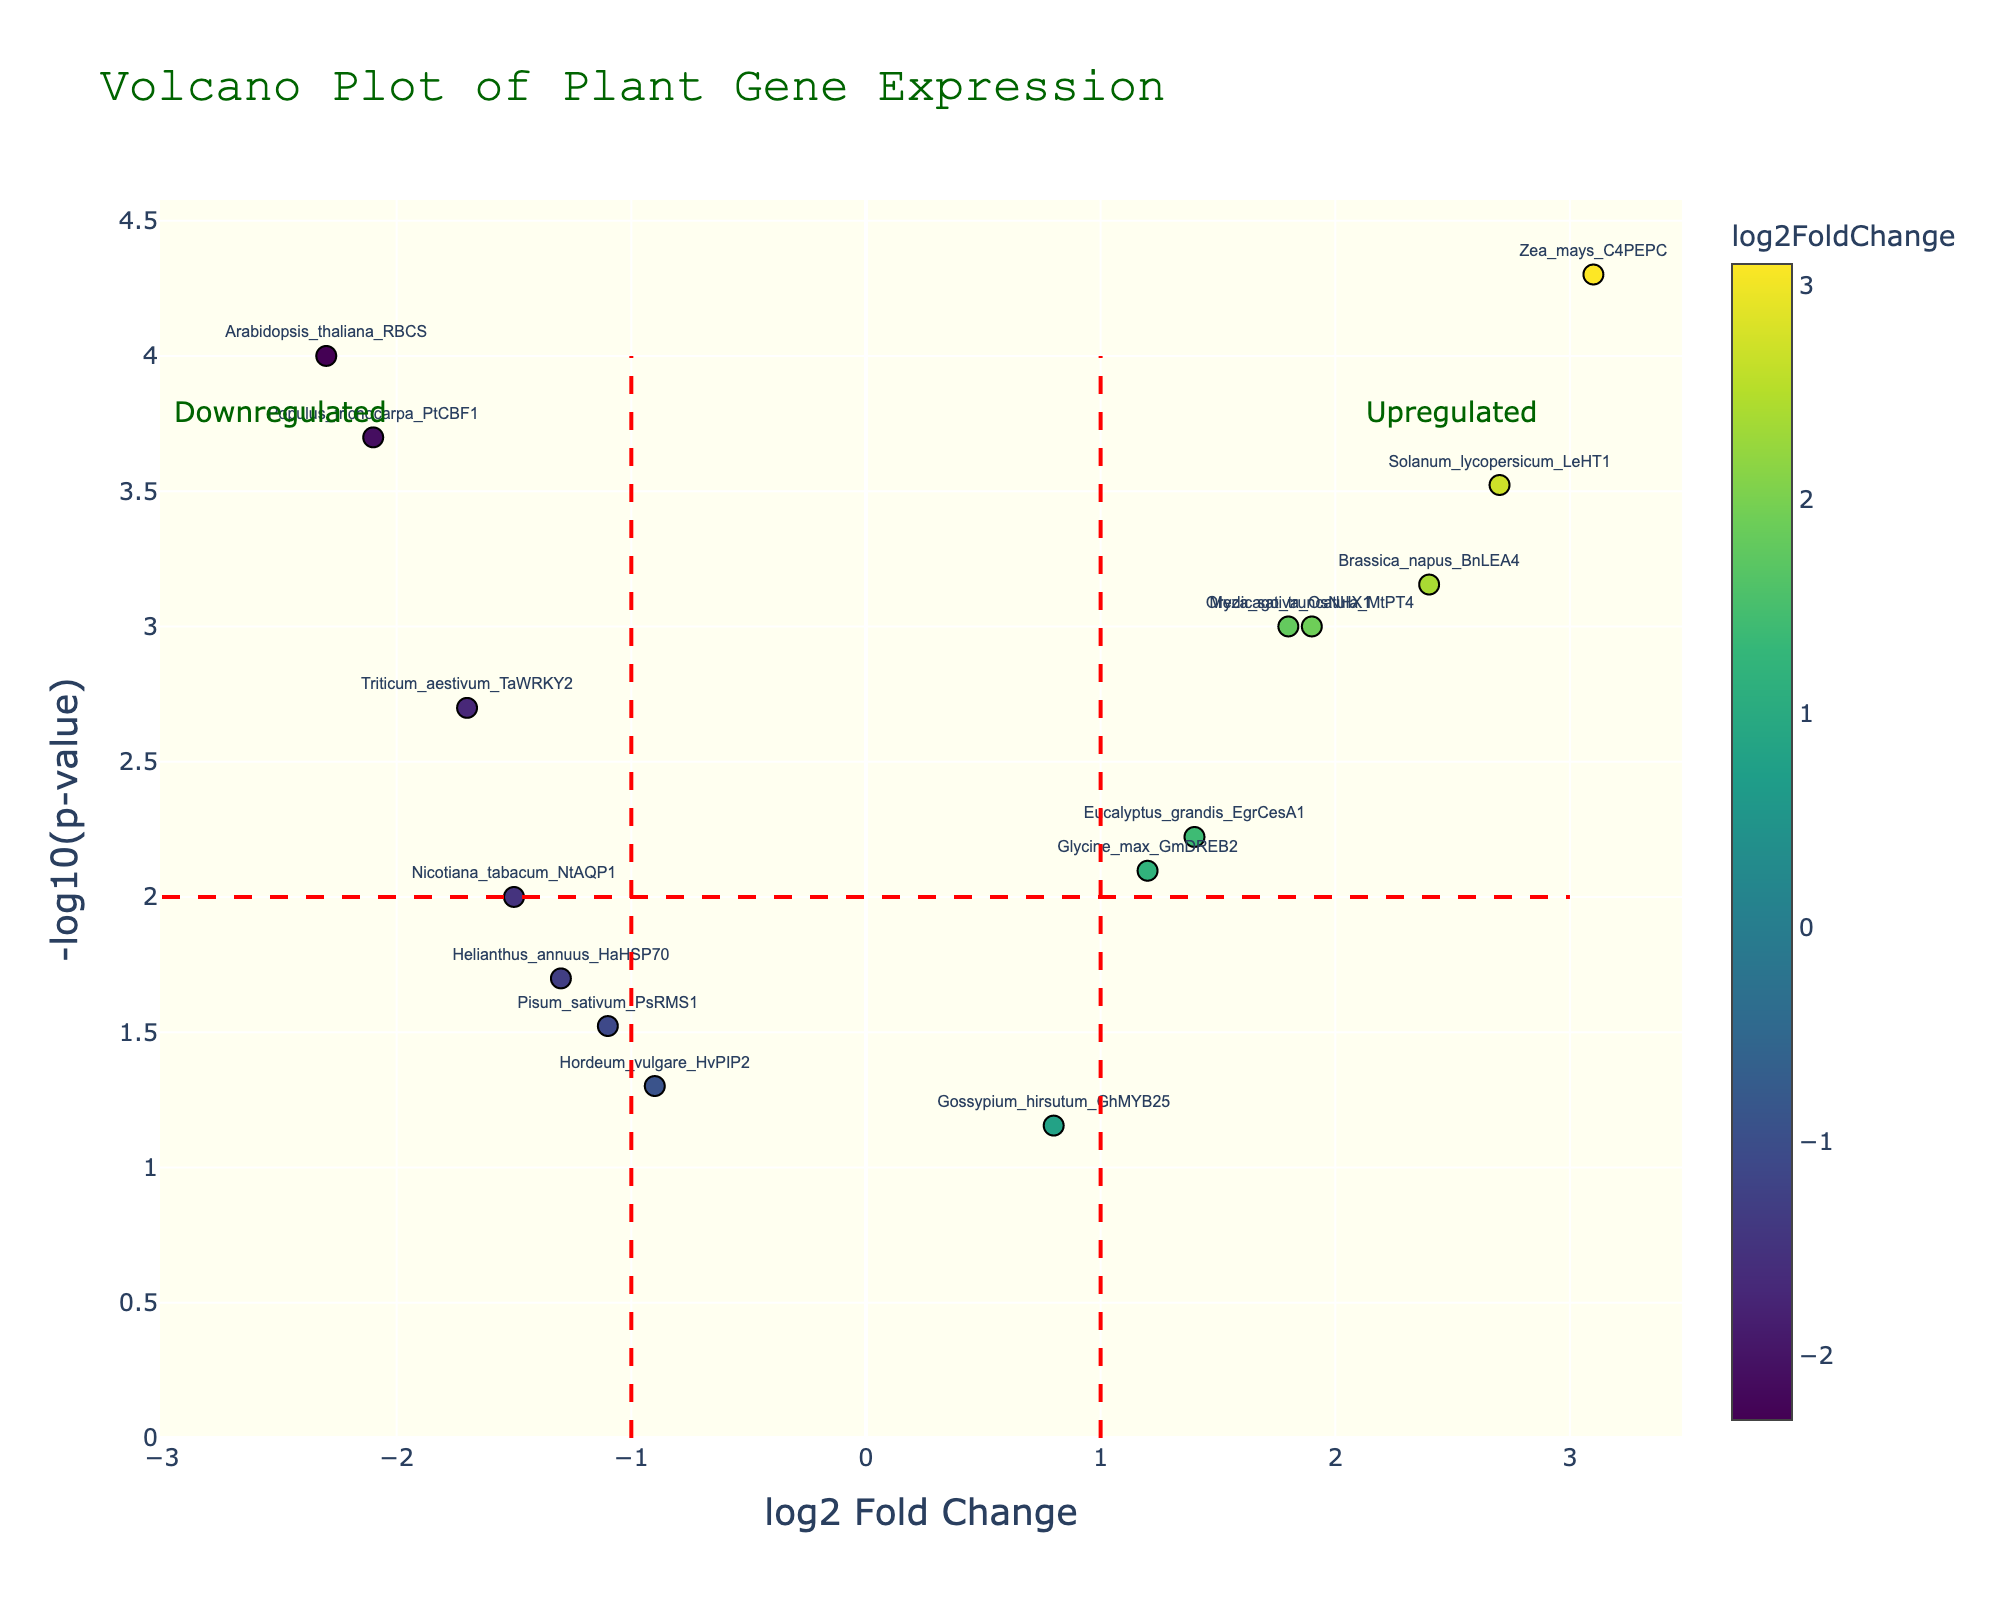What is the title of the plot? The title of the plot is prominently displayed at the top center and reads "Volcano Plot of Plant Gene Expression".
Answer: Volcano Plot of Plant Gene Expression What are the axes labels in the figure? The figure has two axes: the x-axis is labeled "log2 Fold Change" and the y-axis is labeled "-log10(p-value)".
Answer: log2 Fold Change, -log10(p-value) How many genes are labeled in the plot? By visually counting the number of data points annotated with gene names, there are 15 labeled genes in the plot.
Answer: 15 Which gene shows the greatest upregulation? The gene with the highest log2 Fold Change value represents the greatest upregulation, which is "Zea_mays_C4PEPC" with a log2 Fold Change of 3.1.
Answer: Zea_mays_C4PEPC What color scale is used in the plot? The color scale used is "Viridis", which moves from dark to light shades according to the log2 Fold Change values.
Answer: Viridis Which gene is most downregulated in the plot? The gene with the most negative log2 Fold Change value indicates the greatest downregulation, which is "Arabidopsis_thaliana_RBCS" with a log2 Fold Change of -2.3.
Answer: Arabidopsis_thaliana_RBCS How many genes have a log2 Fold Change greater than 1 and a p-value less than 0.001? Genes meeting these criteria will appear to the right of the x=1 line and above the y=3 line. These genes are "Zea_mays_C4PEPC" and "Solanum_lycopersicum_LeHT1".
Answer: 2 Compare the log2 Fold Change for "Nicotiana_tabacum_NtAQP1" and "Triticum_aestivum_TaWRKY2". Which one is more downregulated? "Nicotiana_tabacum_NtAQP1" has a log2 Fold Change of -1.5, and "Triticum_aestivum_TaWRKY2" has a log2 Fold Change of -1.7. Since -1.7 is more negative than -1.5, "Triticum_aestivum_TaWRKY2" is more downregulated.
Answer: Triticum_aestivum_TaWRKY2 What is the range of log2 Fold Change values observed in the plot? The log2 Fold Change values range from the most negative value for "Arabidopsis_thaliana_RBCS" (-2.3) to the most positive value for "Zea_mays_C4PEPC" (3.1).
Answer: -2.3 to 3.1 How many genes have a p-value greater than 0.01? Genes with a p-value greater than 0.01 will appear below the y=2 line. These genes are "Hordeum_vulgare_HvPIP2", "Pisum_sativum_PsRMS1", and "Gossypium_hirsutum_GhMYB25".
Answer: 3 